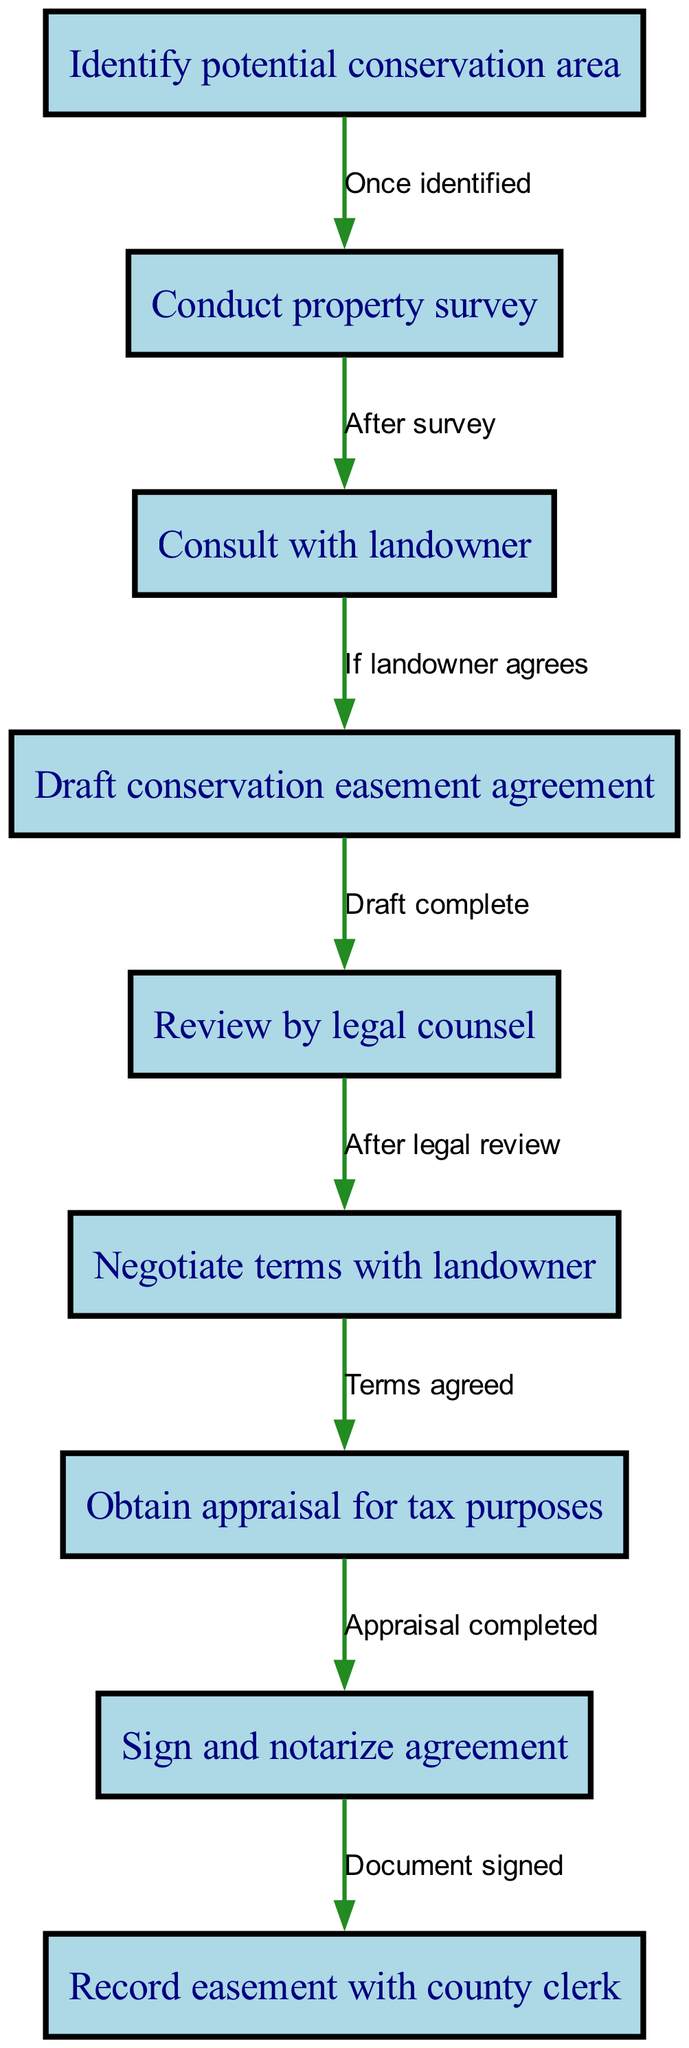What is the first step in establishing a conservation easement? The first step in this process, as indicated by the diagram, is to "Identify potential conservation area."
Answer: Identify potential conservation area How many nodes are present in the flowchart? By counting all the nodes listed in the diagram, I find there are nine nodes total, representing different steps in the process.
Answer: Nine What follows after obtaining the appraisal for tax purposes? After the appraisal is completed, the next step is to "Sign and notarize agreement," according to the connections in the flowchart.
Answer: Sign and notarize agreement Which step occurs after the legal review of the conservation easement agreement? The step that follows the legal review, as shown in the diagram, is to "Negotiate terms with landowner," which is directly connected to the review by legal counsel.
Answer: Negotiate terms with landowner If the landowner agrees, what is the next action in the process? Following landowner agreement, the flowchart indicates that the next step is to "Draft conservation easement agreement," establishing the connection based on the conditions given.
Answer: Draft conservation easement agreement What stage comes immediately before recording the easement with the county clerk? The stage that immediately precedes recording the easement is "Sign and notarize agreement." This is indicated by a direct connection in the flowchart.
Answer: Sign and notarize agreement What is the relationship between the property survey and the consultation with the landowner? According to the diagram, the relationship is that "After survey," the next action is to "Consult with landowner," indicating a sequential dependency between these steps.
Answer: After survey What are the final two steps in the conservation easement establishment process? The final two steps, based on the flowchart, are "Sign and notarize agreement" followed by "Record easement with county clerk," completing the process.
Answer: Sign and notarize agreement, Record easement with county clerk How do you get from negotiating terms with landowner to obtaining an appraisal? After the terms have been agreed upon with the landowner, the next step, as per the flow chart, is to "Obtain appraisal for tax purposes." This indicates a progression from agreement to the appraisal requirement.
Answer: Obtain appraisal for tax purposes 